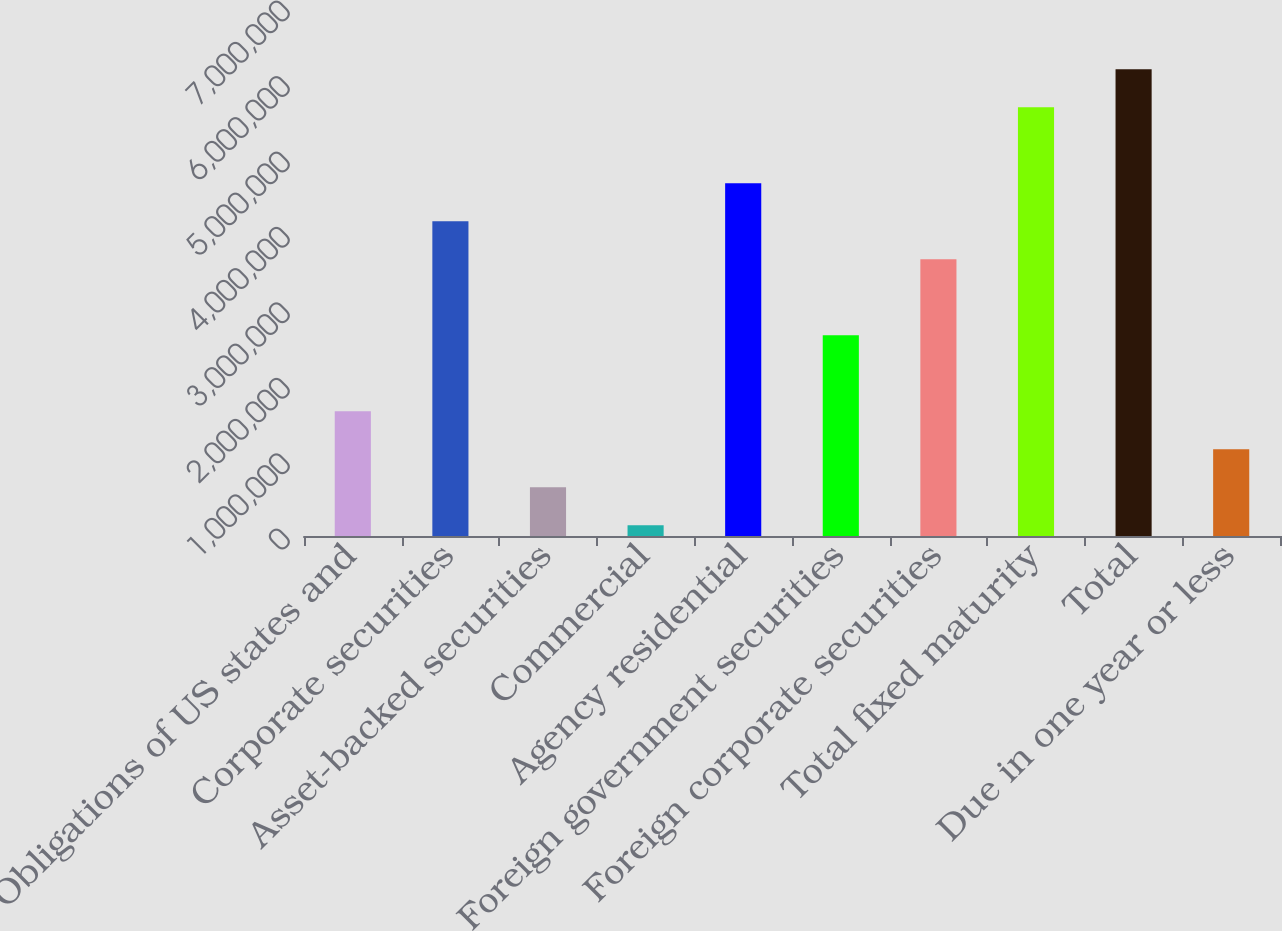Convert chart to OTSL. <chart><loc_0><loc_0><loc_500><loc_500><bar_chart><fcel>Obligations of US states and<fcel>Corporate securities<fcel>Asset-backed securities<fcel>Commercial<fcel>Agency residential<fcel>Foreign government securities<fcel>Foreign corporate securities<fcel>Total fixed maturity<fcel>Total<fcel>Due in one year or less<nl><fcel>1.65461e+06<fcel>4.17304e+06<fcel>647239<fcel>143554<fcel>4.67672e+06<fcel>2.66198e+06<fcel>3.66935e+06<fcel>5.68409e+06<fcel>6.18778e+06<fcel>1.15092e+06<nl></chart> 